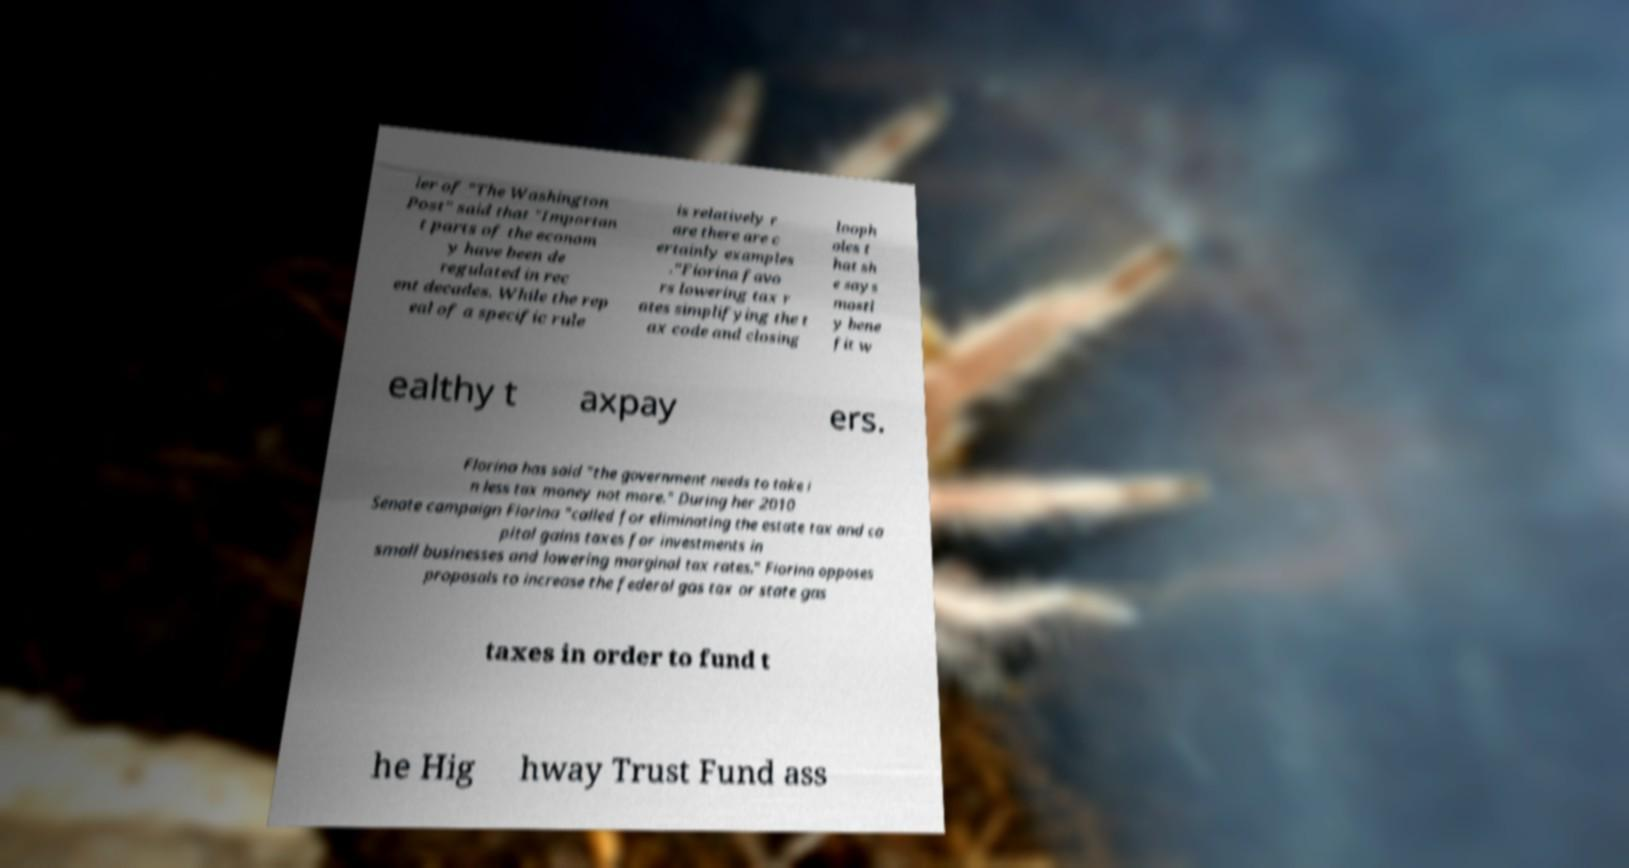I need the written content from this picture converted into text. Can you do that? ler of "The Washington Post" said that "Importan t parts of the econom y have been de regulated in rec ent decades. While the rep eal of a specific rule is relatively r are there are c ertainly examples ."Fiorina favo rs lowering tax r ates simplifying the t ax code and closing looph oles t hat sh e says mostl y bene fit w ealthy t axpay ers. Florina has said "the government needs to take i n less tax money not more." During her 2010 Senate campaign Fiorina "called for eliminating the estate tax and ca pital gains taxes for investments in small businesses and lowering marginal tax rates." Fiorina opposes proposals to increase the federal gas tax or state gas taxes in order to fund t he Hig hway Trust Fund ass 